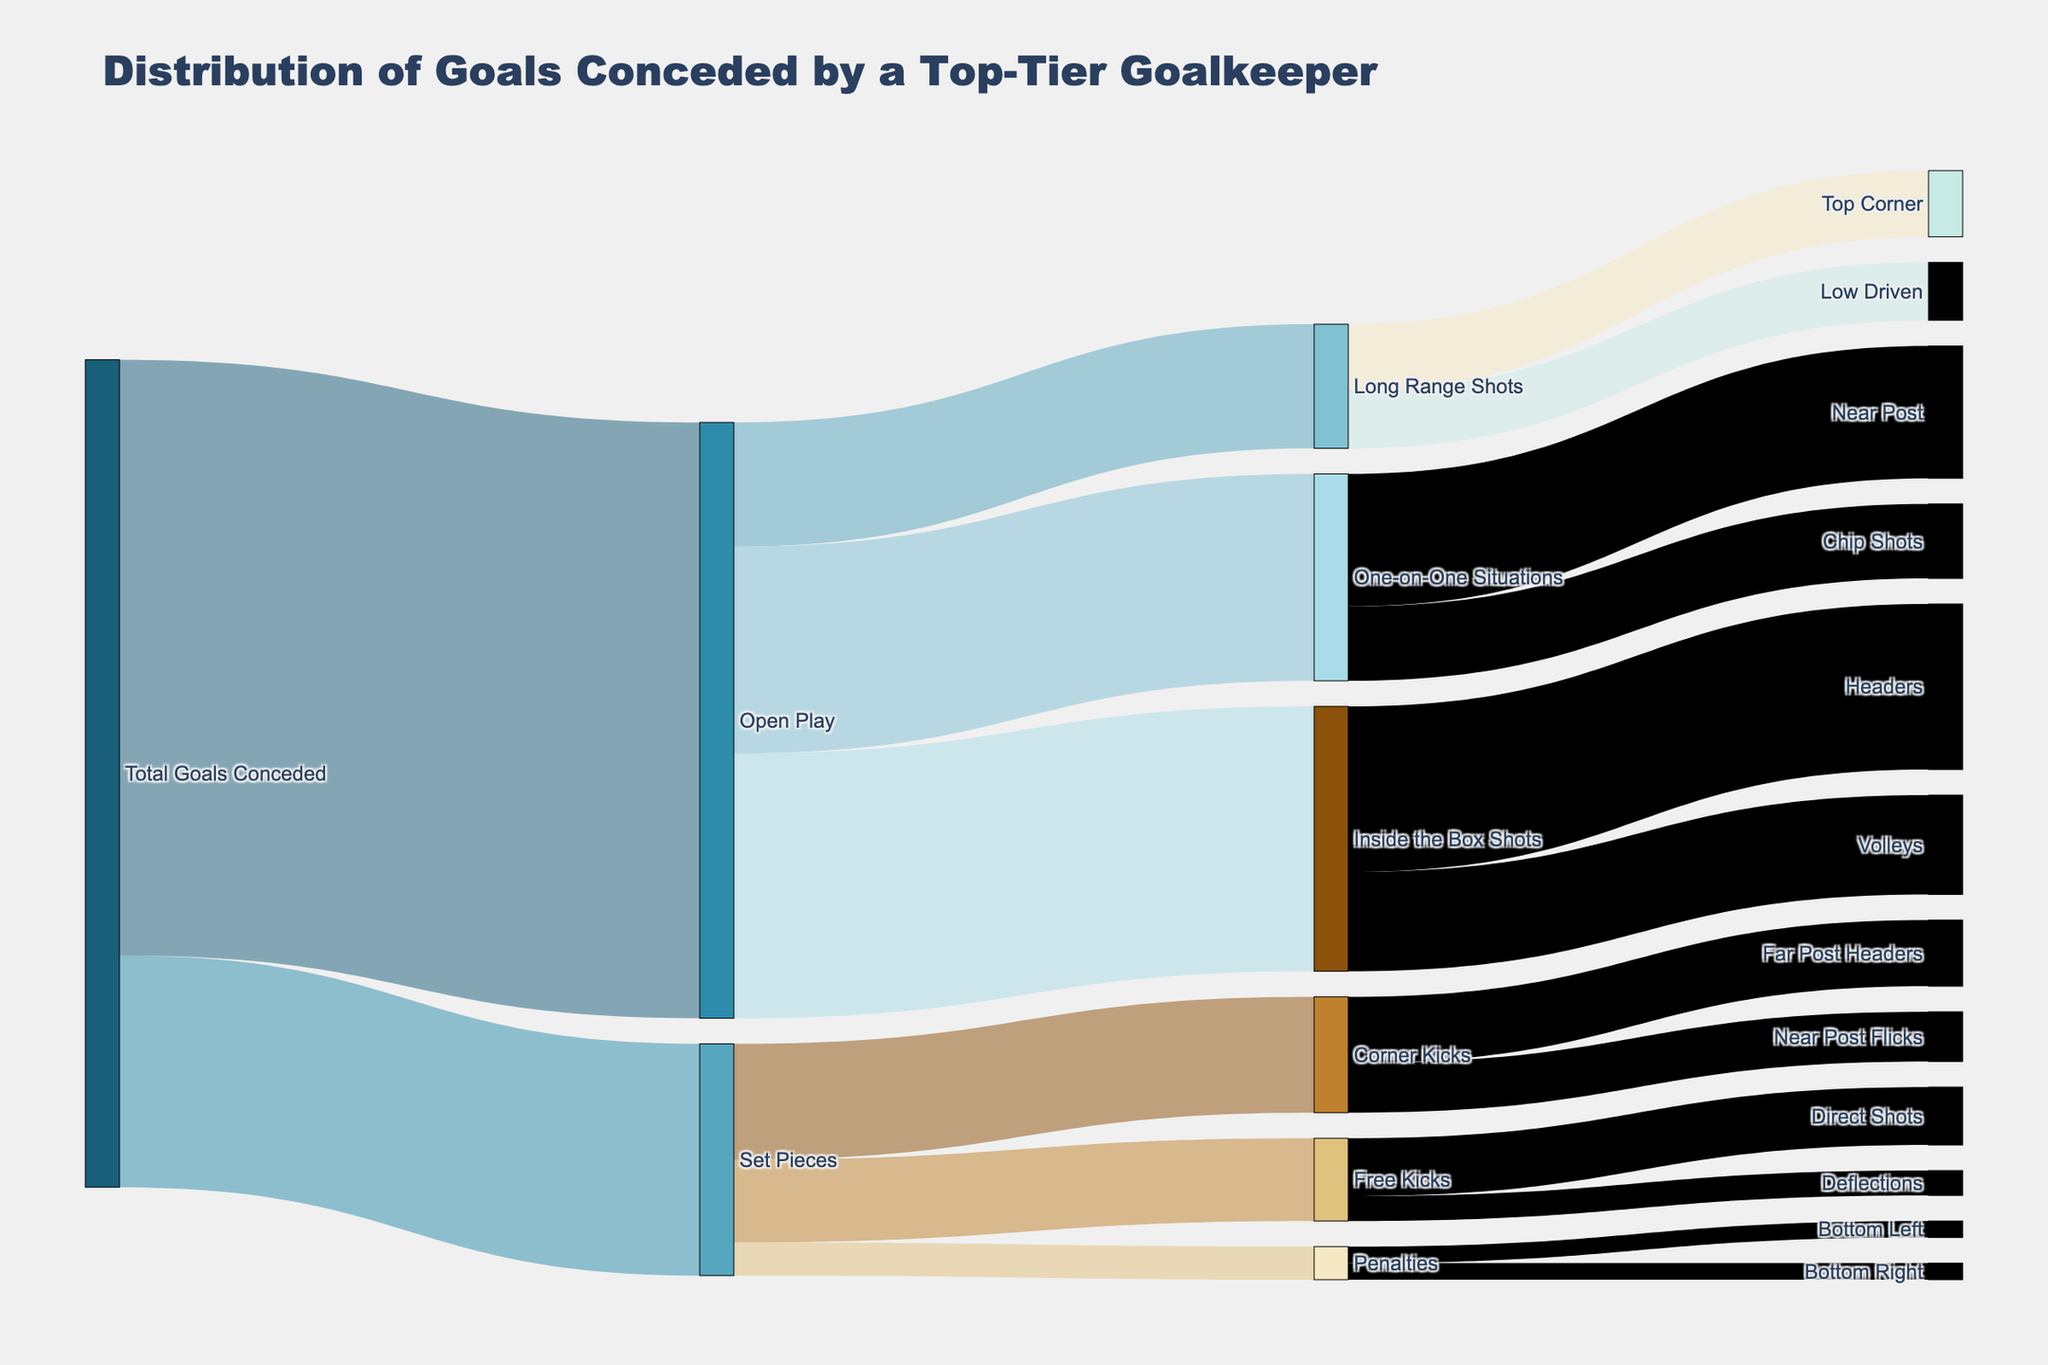What is the title of the Sankey diagram? The title of a chart is typically located at the top of the figure, providing a summary of what the chart represents. In this case, the title helps us understand that the chart visualizes the distribution of goals conceded by a top-tier goalkeeper.
Answer: Distribution of Goals Conceded by a Top-Tier Goalkeeper How many goals were conceded from set pieces? By looking at the connections stemming from "Set Pieces" in the Sankey diagram, we see the total number of goals conceded in this category. This is provided by the value connected to "Total Goals Conceded" leading to "Set Pieces."
Answer: 28 What type of shot conceded under "Open Play" contributed the most goals? To find this, look at the branches that stem from "Open Play." Each branch leading to different shot types will have a value associated with it. The shot type with the highest value is the one that contributed the most.
Answer: Inside the Box Shots How many goals were conceded from "Corner Kicks"? Look at the branch stemming from "Set Pieces" leading to "Corner Kicks" and sum the values of all branches stemming from "Corner Kicks" to get the total.
Answer: 14 What are the penalties distribution among the different corners? Examine the branches stemming from "Penalties"; it will lead to different corners where the penalties were scored. Sum them up to get the distribution.
Answer: Bottom Left: 2, Bottom Right: 2 Which type of "Long Range Shot" is more frequent, "Top Corner" or "Low Driven"? Compare the values of the branches from "Long Range Shots" leading to "Top Corner" and "Low Driven." The higher value indicates the more frequent shot type.
Answer: Top Corner Calculate the total goals conceded from "One-on-One Situations". Sum the values of the branches stemming from "One-on-One Situations" leading to specific shot outcomes.
Answer: 25 Which set piece resulted in the fewest goals? Examine the branches stemming from "Set Pieces" and compare their values. The branch with the smallest value represents the set piece that resulted in the fewest goals.
Answer: Penalties How many goals were conceded from "Volleys" and "Headers" combined? Look at the values of the branches stemming from "Inside the Box Shots" leading to "Volleys" and "Headers," and sum them up to get the total.
Answer: 12 + 20 = 32 Compare the number of goals conceded through "Direct Shots" from free kicks and "Deflections" from free kicks. Which is higher? Examine the branches stemming from "Free Kicks" leading to "Direct Shots" and "Deflections," and compare their values.
Answer: Direct Shots 